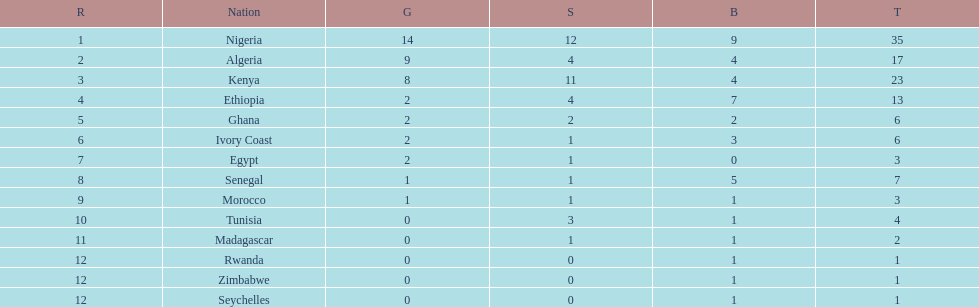Which nations have won only one medal? Rwanda, Zimbabwe, Seychelles. 